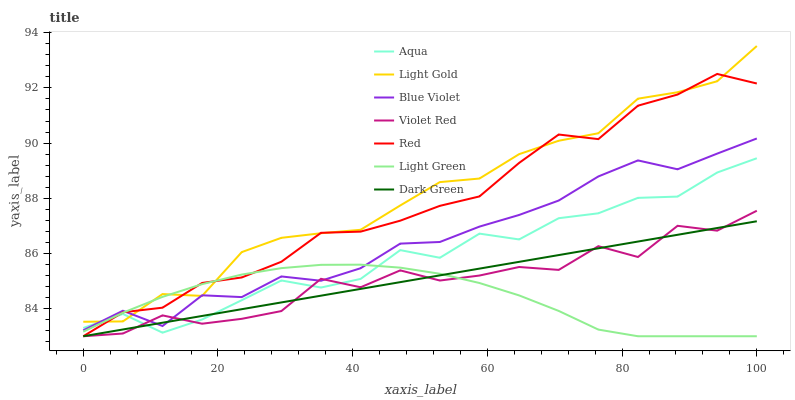Does Light Green have the minimum area under the curve?
Answer yes or no. Yes. Does Light Gold have the maximum area under the curve?
Answer yes or no. Yes. Does Aqua have the minimum area under the curve?
Answer yes or no. No. Does Aqua have the maximum area under the curve?
Answer yes or no. No. Is Dark Green the smoothest?
Answer yes or no. Yes. Is Violet Red the roughest?
Answer yes or no. Yes. Is Aqua the smoothest?
Answer yes or no. No. Is Aqua the roughest?
Answer yes or no. No. Does Violet Red have the lowest value?
Answer yes or no. Yes. Does Aqua have the lowest value?
Answer yes or no. No. Does Light Gold have the highest value?
Answer yes or no. Yes. Does Aqua have the highest value?
Answer yes or no. No. Is Violet Red less than Light Gold?
Answer yes or no. Yes. Is Light Gold greater than Dark Green?
Answer yes or no. Yes. Does Blue Violet intersect Red?
Answer yes or no. Yes. Is Blue Violet less than Red?
Answer yes or no. No. Is Blue Violet greater than Red?
Answer yes or no. No. Does Violet Red intersect Light Gold?
Answer yes or no. No. 